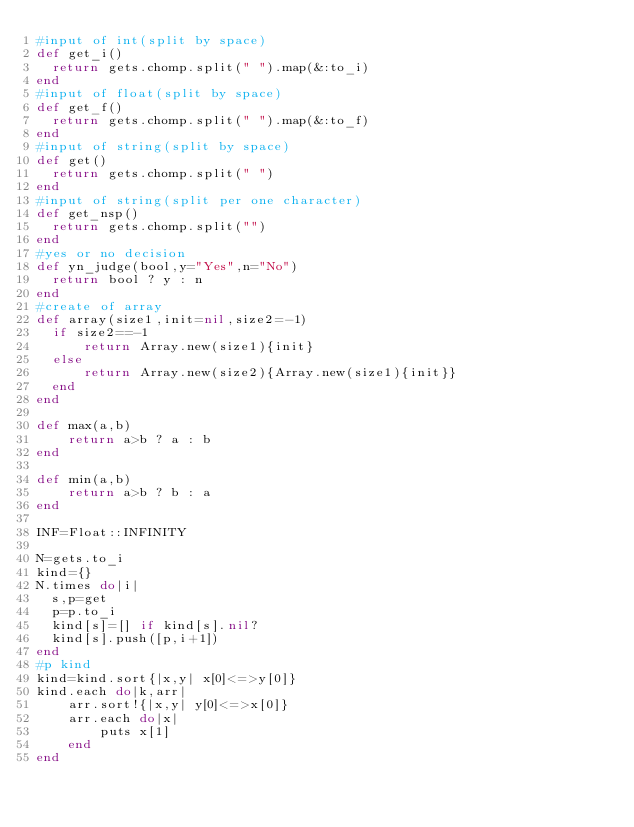Convert code to text. <code><loc_0><loc_0><loc_500><loc_500><_Ruby_>#input of int(split by space)
def get_i()
  return gets.chomp.split(" ").map(&:to_i)
end
#input of float(split by space)
def get_f()
  return gets.chomp.split(" ").map(&:to_f)
end
#input of string(split by space)
def get()
  return gets.chomp.split(" ")
end
#input of string(split per one character)
def get_nsp()
  return gets.chomp.split("")
end
#yes or no decision
def yn_judge(bool,y="Yes",n="No")
  return bool ? y : n 
end
#create of array
def array(size1,init=nil,size2=-1)
  if size2==-1
      return Array.new(size1){init}
  else
      return Array.new(size2){Array.new(size1){init}}
  end
end

def max(a,b)
    return a>b ? a : b
end

def min(a,b)
    return a>b ? b : a
end

INF=Float::INFINITY

N=gets.to_i
kind={}
N.times do|i|
  s,p=get
  p=p.to_i
  kind[s]=[] if kind[s].nil?
  kind[s].push([p,i+1])
end
#p kind
kind=kind.sort{|x,y| x[0]<=>y[0]}
kind.each do|k,arr|
    arr.sort!{|x,y| y[0]<=>x[0]}
    arr.each do|x|
        puts x[1]
    end
end</code> 